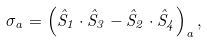Convert formula to latex. <formula><loc_0><loc_0><loc_500><loc_500>\sigma _ { a } = \left ( \hat { S } _ { 1 } \cdot \hat { S } _ { 3 } - \hat { S } _ { 2 } \cdot \hat { S } _ { 4 } \right ) _ { a } ,</formula> 